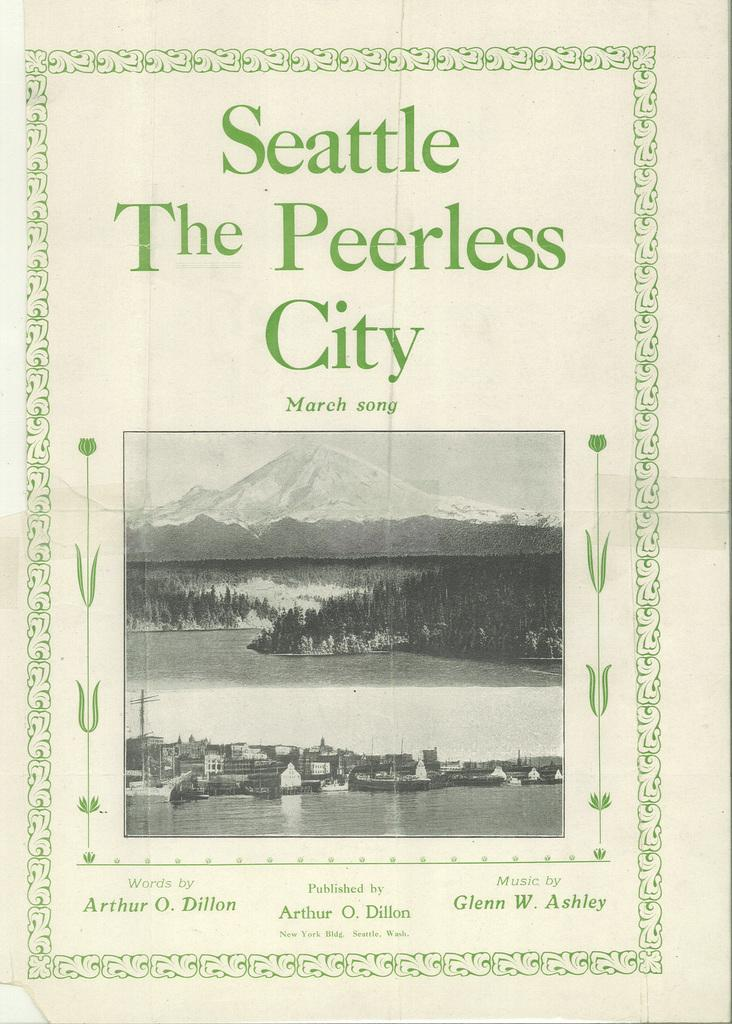What is featured on the poster in the picture? There is a poster with an image and text in the picture. What types of structures are depicted in the image on the poster? The image on the poster contains buildings. What natural elements are present in the image on the poster? The image on the poster contains trees, mountains, plants, water, and the sky. How many chairs are visible in the image on the poster? There are no chairs present in the image on the poster. What type of mist can be seen surrounding the mountains in the image on the poster? There is no mist present in the image on the poster; it only contains buildings, trees, mountains, plants, water, and the sky. 